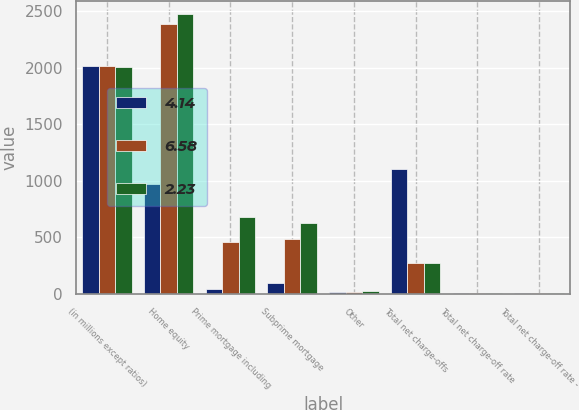Convert chart. <chart><loc_0><loc_0><loc_500><loc_500><stacked_bar_chart><ecel><fcel>(in millions except ratios)<fcel>Home equity<fcel>Prime mortgage including<fcel>Subprime mortgage<fcel>Other<fcel>Total net charge-offs<fcel>Total net charge-off rate<fcel>Total net charge-off rate -<nl><fcel>4.14<fcel>2013<fcel>966<fcel>41<fcel>90<fcel>10<fcel>1107<fcel>0.96<fcel>0.64<nl><fcel>6.58<fcel>2012<fcel>2385<fcel>454<fcel>486<fcel>16<fcel>272<fcel>2.68<fcel>1.79<nl><fcel>2.23<fcel>2011<fcel>2472<fcel>682<fcel>626<fcel>25<fcel>272<fcel>2.7<fcel>1.81<nl></chart> 